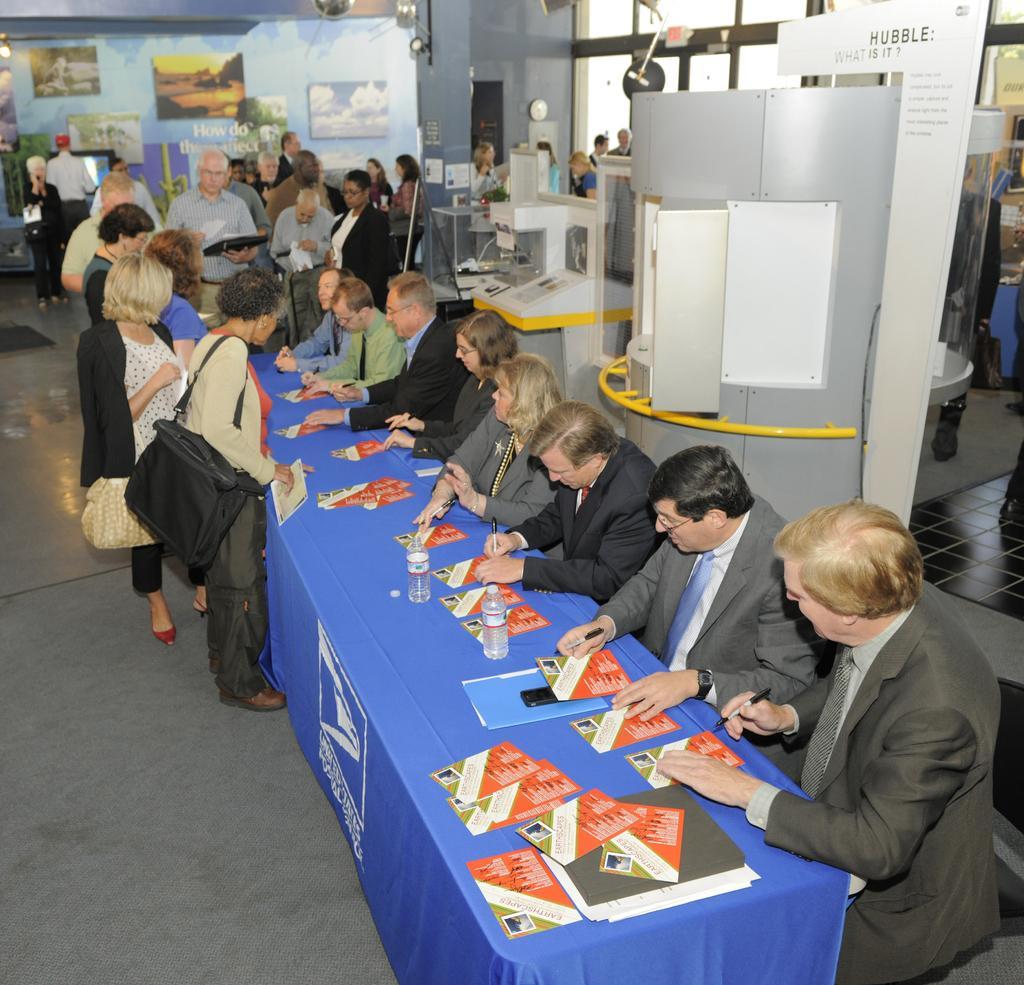Please provide a concise description of this image. The picture is taken in a building. In the center of the picture there is a table, on the table there are pamphlets, files, water bottles. Around the desk there are people. In the background there are people, banner and other objects. On the right there are banner and other objects. 